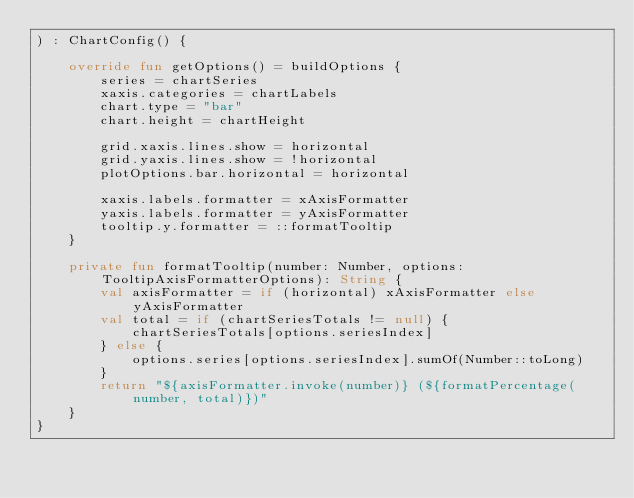<code> <loc_0><loc_0><loc_500><loc_500><_Kotlin_>) : ChartConfig() {

    override fun getOptions() = buildOptions {
        series = chartSeries
        xaxis.categories = chartLabels
        chart.type = "bar"
        chart.height = chartHeight

        grid.xaxis.lines.show = horizontal
        grid.yaxis.lines.show = !horizontal
        plotOptions.bar.horizontal = horizontal

        xaxis.labels.formatter = xAxisFormatter
        yaxis.labels.formatter = yAxisFormatter
        tooltip.y.formatter = ::formatTooltip
    }

    private fun formatTooltip(number: Number, options: TooltipAxisFormatterOptions): String {
        val axisFormatter = if (horizontal) xAxisFormatter else yAxisFormatter
        val total = if (chartSeriesTotals != null) {
            chartSeriesTotals[options.seriesIndex]
        } else {
            options.series[options.seriesIndex].sumOf(Number::toLong)
        }
        return "${axisFormatter.invoke(number)} (${formatPercentage(number, total)})"
    }
}
</code> 